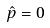Convert formula to latex. <formula><loc_0><loc_0><loc_500><loc_500>\hat { p } = 0</formula> 